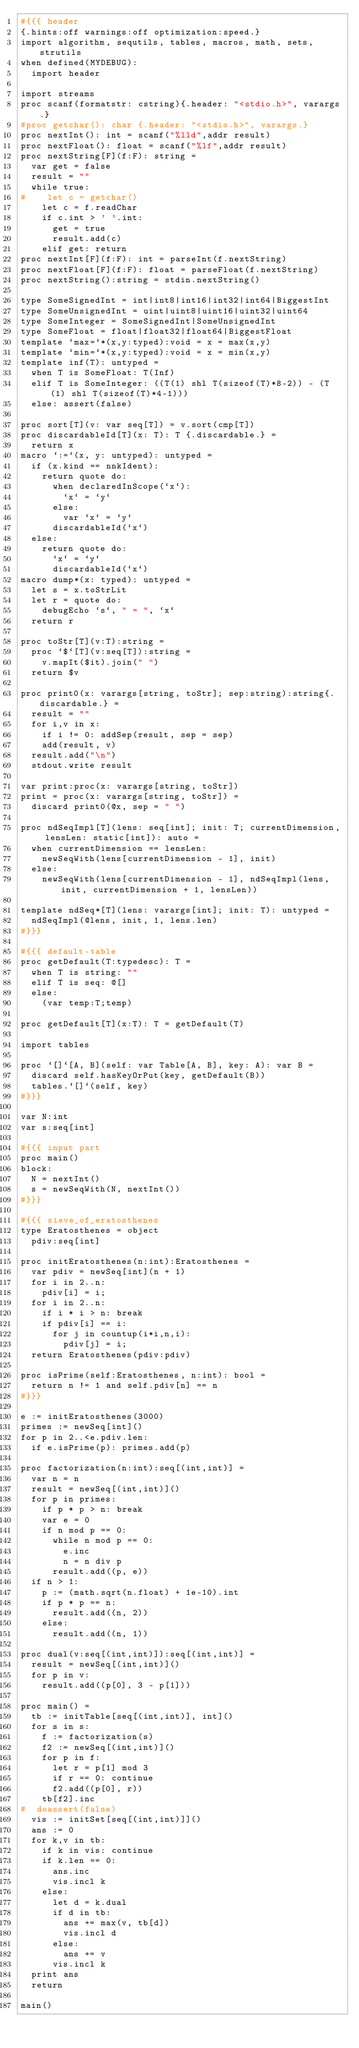Convert code to text. <code><loc_0><loc_0><loc_500><loc_500><_Nim_>#{{{ header
{.hints:off warnings:off optimization:speed.}
import algorithm, sequtils, tables, macros, math, sets, strutils
when defined(MYDEBUG):
  import header

import streams
proc scanf(formatstr: cstring){.header: "<stdio.h>", varargs.}
#proc getchar(): char {.header: "<stdio.h>", varargs.}
proc nextInt(): int = scanf("%lld",addr result)
proc nextFloat(): float = scanf("%lf",addr result)
proc nextString[F](f:F): string =
  var get = false
  result = ""
  while true:
#    let c = getchar()
    let c = f.readChar
    if c.int > ' '.int:
      get = true
      result.add(c)
    elif get: return
proc nextInt[F](f:F): int = parseInt(f.nextString)
proc nextFloat[F](f:F): float = parseFloat(f.nextString)
proc nextString():string = stdin.nextString()

type SomeSignedInt = int|int8|int16|int32|int64|BiggestInt
type SomeUnsignedInt = uint|uint8|uint16|uint32|uint64
type SomeInteger = SomeSignedInt|SomeUnsignedInt
type SomeFloat = float|float32|float64|BiggestFloat
template `max=`*(x,y:typed):void = x = max(x,y)
template `min=`*(x,y:typed):void = x = min(x,y)
template inf(T): untyped = 
  when T is SomeFloat: T(Inf)
  elif T is SomeInteger: ((T(1) shl T(sizeof(T)*8-2)) - (T(1) shl T(sizeof(T)*4-1)))
  else: assert(false)

proc sort[T](v: var seq[T]) = v.sort(cmp[T])
proc discardableId[T](x: T): T {.discardable.} =
  return x
macro `:=`(x, y: untyped): untyped =
  if (x.kind == nnkIdent):
    return quote do:
      when declaredInScope(`x`):
        `x` = `y`
      else:
        var `x` = `y`
      discardableId(`x`)
  else:
    return quote do:
      `x` = `y`
      discardableId(`x`)
macro dump*(x: typed): untyped =
  let s = x.toStrLit
  let r = quote do:
    debugEcho `s`, " = ", `x`
  return r

proc toStr[T](v:T):string =
  proc `$`[T](v:seq[T]):string =
    v.mapIt($it).join(" ")
  return $v

proc print0(x: varargs[string, toStr]; sep:string):string{.discardable.} =
  result = ""
  for i,v in x:
    if i != 0: addSep(result, sep = sep)
    add(result, v)
  result.add("\n")
  stdout.write result

var print:proc(x: varargs[string, toStr])
print = proc(x: varargs[string, toStr]) =
  discard print0(@x, sep = " ")

proc ndSeqImpl[T](lens: seq[int]; init: T; currentDimension, lensLen: static[int]): auto =
  when currentDimension == lensLen:
    newSeqWith(lens[currentDimension - 1], init)
  else:
    newSeqWith(lens[currentDimension - 1], ndSeqImpl(lens, init, currentDimension + 1, lensLen))

template ndSeq*[T](lens: varargs[int]; init: T): untyped =
  ndSeqImpl(@lens, init, 1, lens.len)
#}}}

#{{{ default-table
proc getDefault(T:typedesc): T =
  when T is string: ""
  elif T is seq: @[]
  else:
    (var temp:T;temp)

proc getDefault[T](x:T): T = getDefault(T)

import tables

proc `[]`[A, B](self: var Table[A, B], key: A): var B =
  discard self.hasKeyOrPut(key, getDefault(B))
  tables.`[]`(self, key)
#}}}

var N:int
var s:seq[int]

#{{{ input part
proc main()
block:
  N = nextInt()
  s = newSeqWith(N, nextInt())
#}}}

#{{{ sieve_of_eratosthenes
type Eratosthenes = object
  pdiv:seq[int]

proc initEratosthenes(n:int):Eratosthenes =
  var pdiv = newSeq[int](n + 1)
  for i in 2..n:
    pdiv[i] = i;
  for i in 2..n:
    if i * i > n: break
    if pdiv[i] == i:
      for j in countup(i*i,n,i):
        pdiv[j] = i;
  return Eratosthenes(pdiv:pdiv)

proc isPrime(self:Eratosthenes, n:int): bool =
  return n != 1 and self.pdiv[n] == n
#}}}

e := initEratosthenes(3000)
primes := newSeq[int]()
for p in 2..<e.pdiv.len:
  if e.isPrime(p): primes.add(p)

proc factorization(n:int):seq[(int,int)] =
  var n = n
  result = newSeq[(int,int)]()
  for p in primes:
    if p * p > n: break
    var e = 0
    if n mod p == 0:
      while n mod p == 0:
        e.inc
        n = n div p
      result.add((p, e))
  if n > 1:
    p := (math.sqrt(n.float) + 1e-10).int
    if p * p == n:
      result.add((n, 2))
    else:
      result.add((n, 1))

proc dual(v:seq[(int,int)]):seq[(int,int)] =
  result = newSeq[(int,int)]()
  for p in v:
    result.add((p[0], 3 - p[1]))

proc main() =
  tb := initTable[seq[(int,int)], int]()
  for s in s:
    f := factorization(s)
    f2 := newSeq[(int,int)]()
    for p in f:
      let r = p[1] mod 3
      if r == 0: continue
      f2.add((p[0], r))
    tb[f2].inc
#  doassert(false)
  vis := initSet[seq[(int,int)]]()
  ans := 0
  for k,v in tb:
    if k in vis: continue
    if k.len == 0:
      ans.inc
      vis.incl k
    else:
      let d = k.dual
      if d in tb:
        ans += max(v, tb[d])
        vis.incl d
      else:
        ans += v
      vis.incl k
  print ans
  return

main()
</code> 